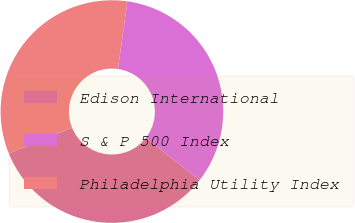Convert chart to OTSL. <chart><loc_0><loc_0><loc_500><loc_500><pie_chart><fcel>Edison International<fcel>S & P 500 Index<fcel>Philadelphia Utility Index<nl><fcel>33.3%<fcel>33.33%<fcel>33.37%<nl></chart> 